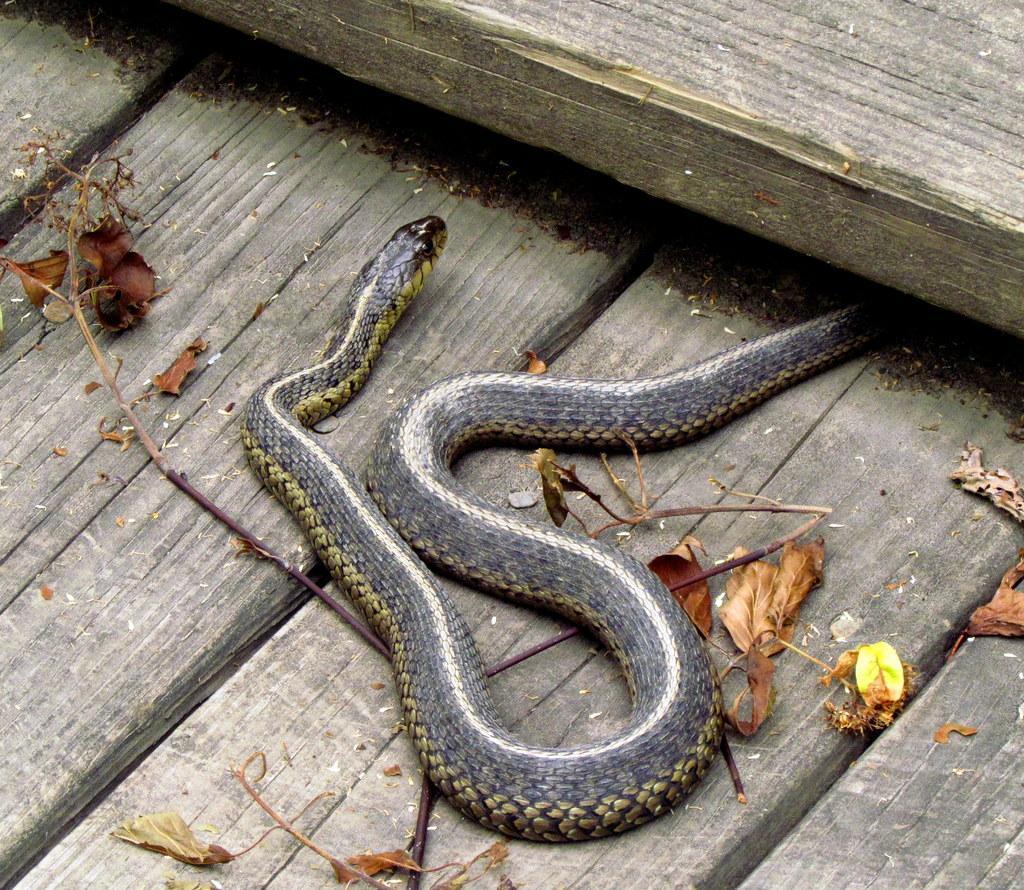In one or two sentences, can you explain what this image depicts? In the image we can see there is a snake on the ground. There are dry leaves and plants on the ground. 